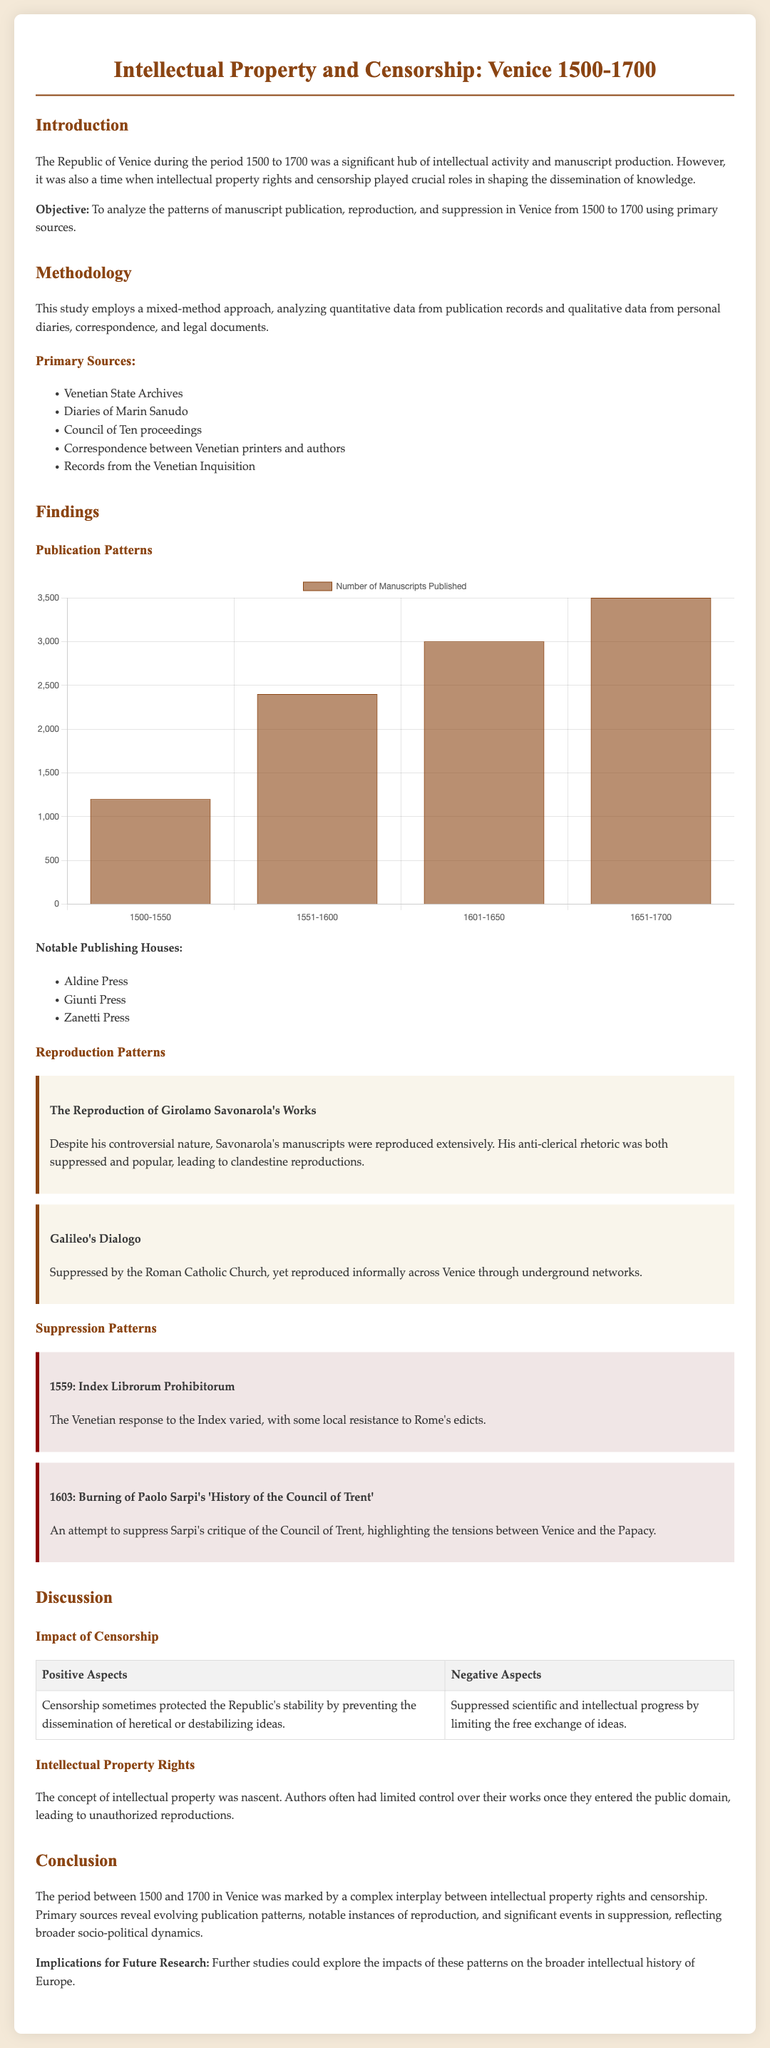What was the objective of the study? The objective of the study is to analyze the patterns of manuscript publication, reproduction, and suppression in Venice from 1500 to 1700 using primary sources.
Answer: Analyze manuscript patterns Which notable publishing house is mentioned first? The first notable publishing house listed in the findings section is Aldine Press.
Answer: Aldine Press How many manuscripts were published in the period 1651-1700? According to the publication chart, the number of manuscripts published between 1651-1700 is 3500.
Answer: 3500 What year was the Index Librorum Prohibitorum introduced? The year when the Index Librorum Prohibitorum was introduced is 1559.
Answer: 1559 What was one positive aspect of censorship mentioned? One positive aspect of censorship mentioned in the document is that it sometimes protected the Republic's stability.
Answer: Protected stability What type of approach is used in the study? The study employs a mixed-method approach.
Answer: Mixed-method approach Which controversial figure's works were reproduced extensively? The works of Girolamo Savonarola were reproduced extensively.
Answer: Girolamo Savonarola Which event involved the burning of Paolo Sarpi's work? The event involving the burning of Paolo Sarpi's work took place in the year 1603.
Answer: 1603 